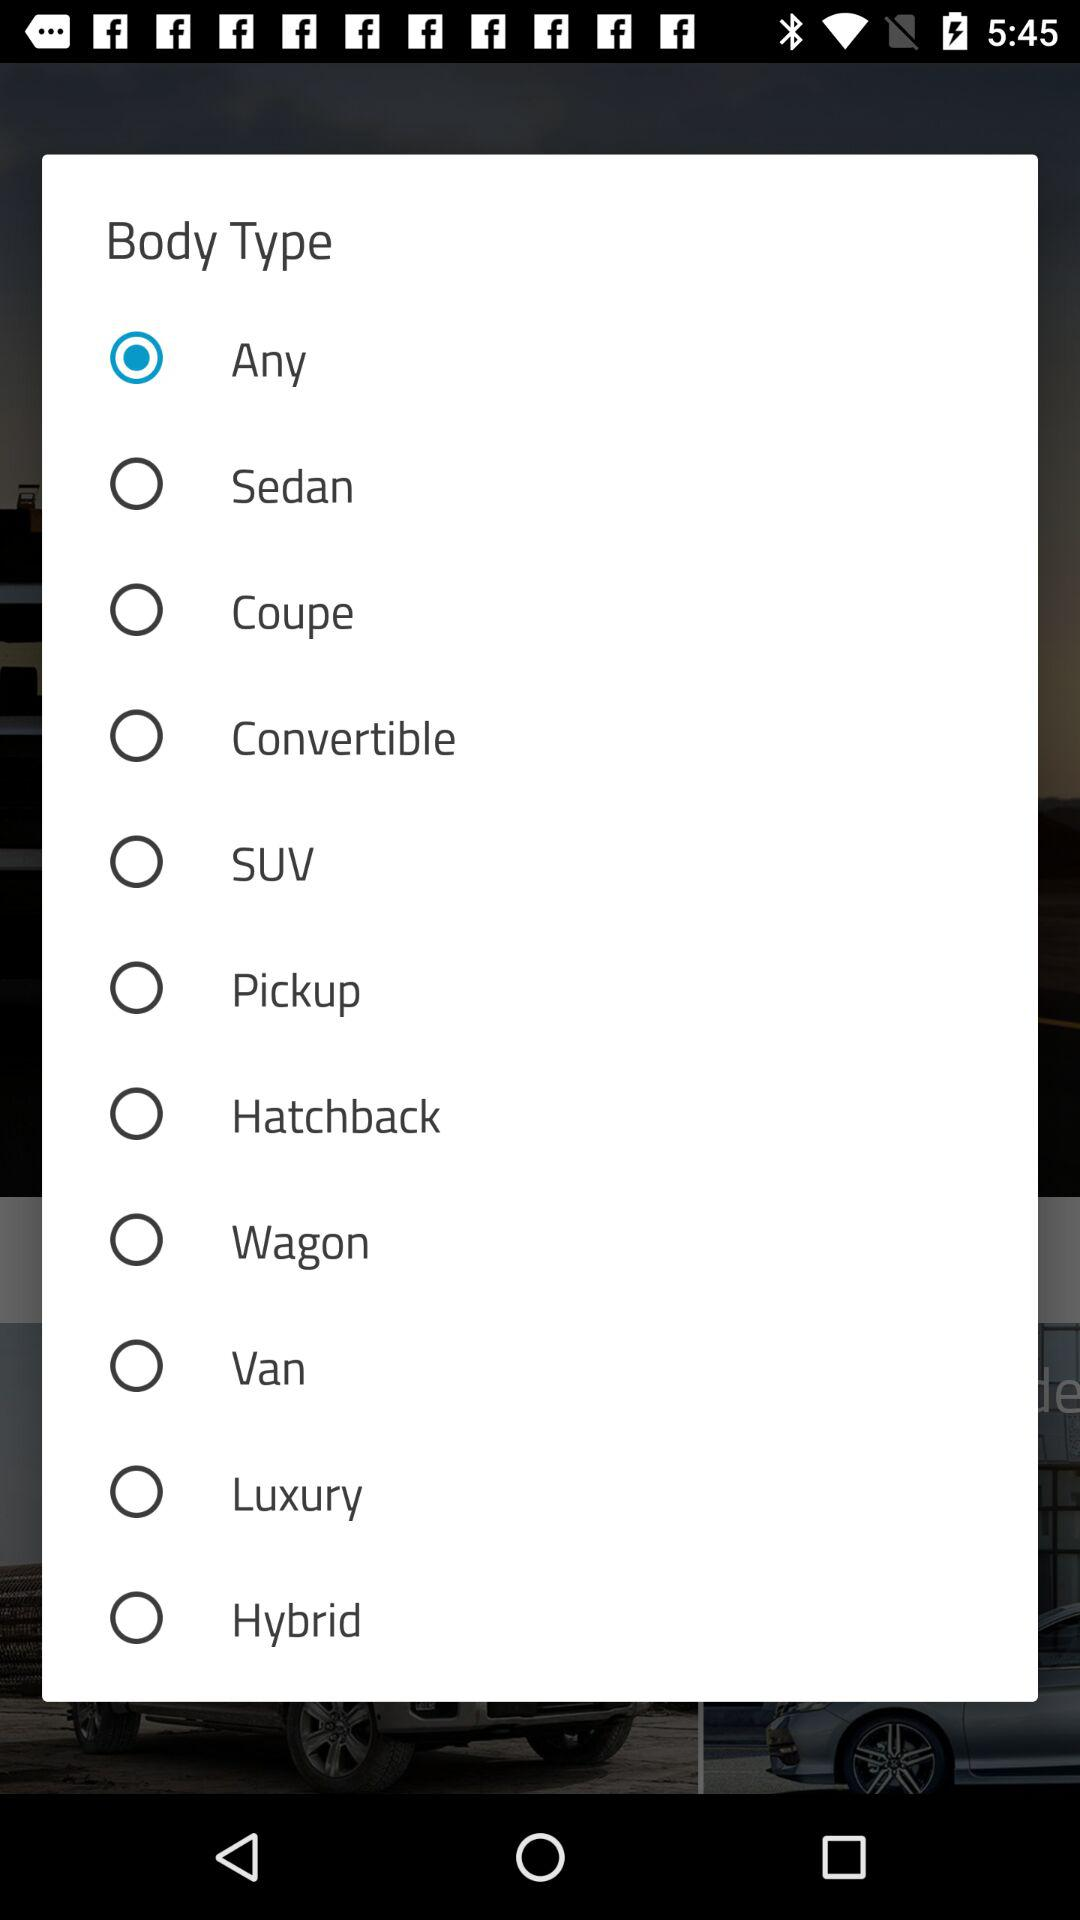Which body type is selected? The selected body type is "Any". 